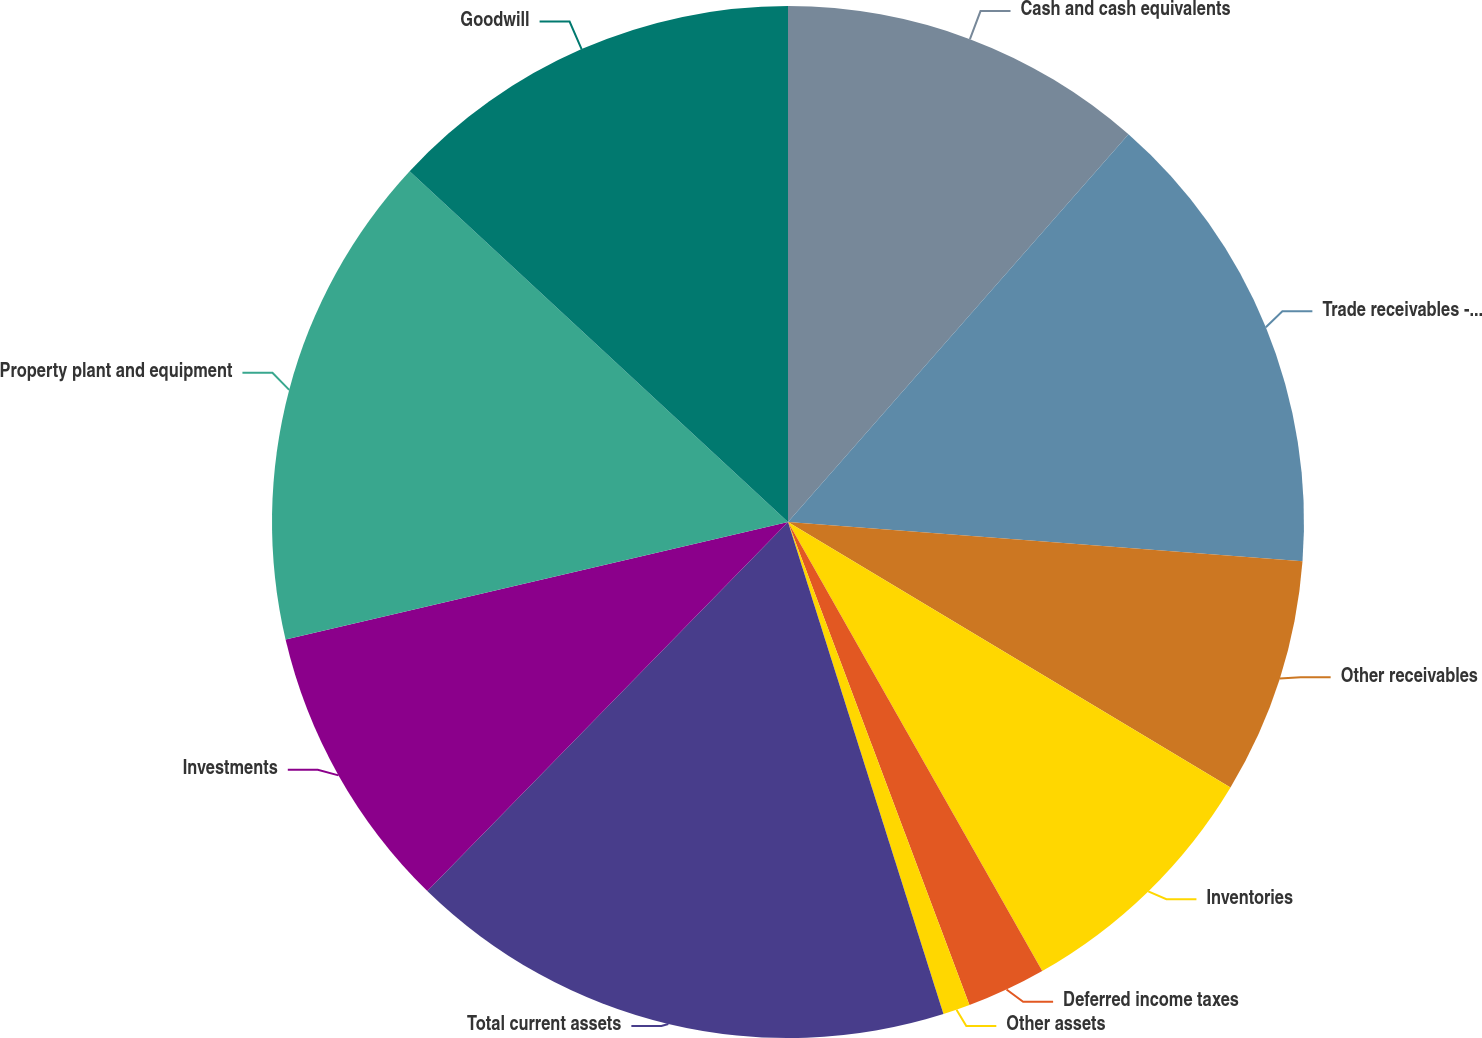<chart> <loc_0><loc_0><loc_500><loc_500><pie_chart><fcel>Cash and cash equivalents<fcel>Trade receivables - third<fcel>Other receivables<fcel>Inventories<fcel>Deferred income taxes<fcel>Other assets<fcel>Total current assets<fcel>Investments<fcel>Property plant and equipment<fcel>Goodwill<nl><fcel>11.47%<fcel>14.74%<fcel>7.39%<fcel>8.2%<fcel>2.48%<fcel>0.85%<fcel>17.19%<fcel>9.02%<fcel>15.56%<fcel>13.1%<nl></chart> 